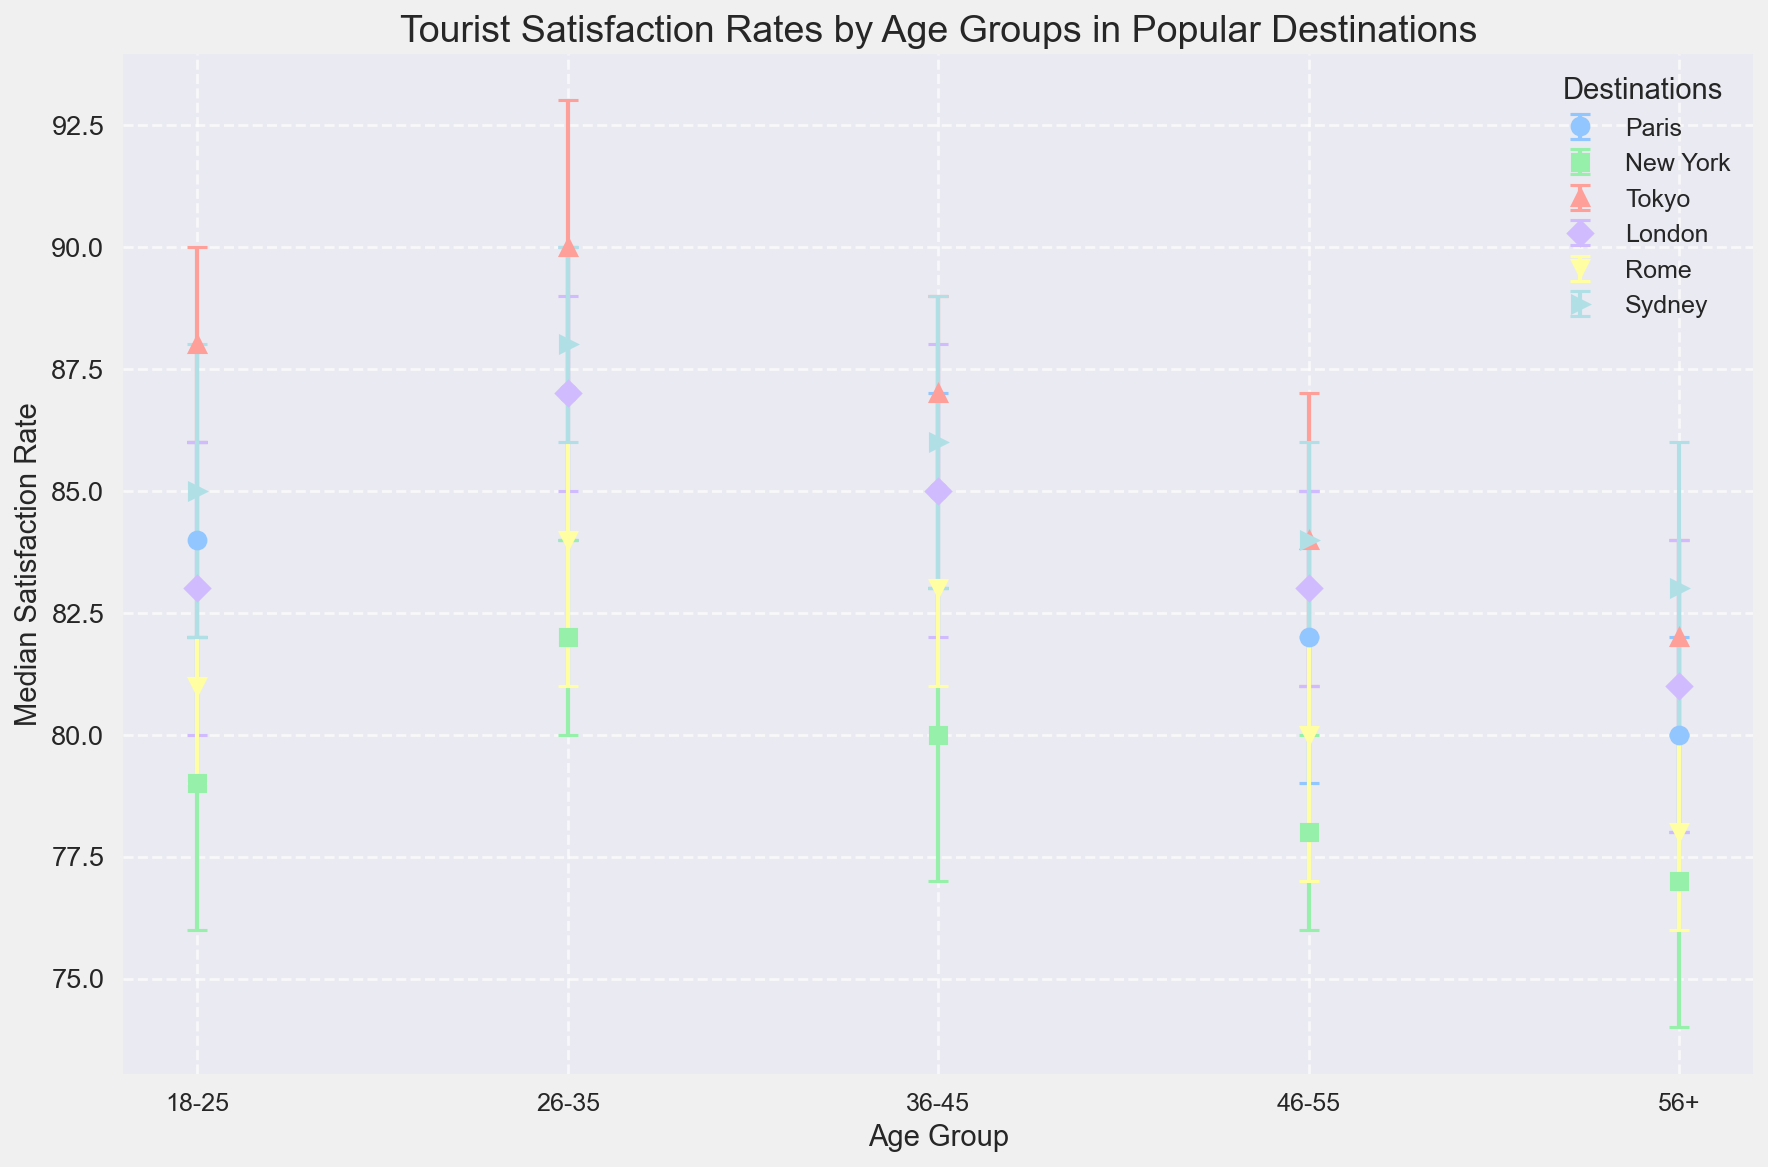Which age group has the highest tourist satisfaction rate in Tokyo? Look at the bars representing Tokyo. The 26-35 age group has the highest bar on the satisfaction rate axis.
Answer: 26-35 Which destination has the lowest median satisfaction rate for the 56+ age group? Locate the satisfaction rates for the 56+ age group across all destinations. New York shows the lowest value at 77.
Answer: New York Compare the error margins for the 18-25 age group in Paris and Sydney. Which one is higher? Look at the error bars for the 18-25 age group in both Paris and Sydney. Sydney has an error margin of 3 while Paris has an error margin of 2.
Answer: Sydney What is the difference in satisfaction rates between the 36-45 age group and 56+ age group in London? For London, the satisfaction rate for the 36-45 age group is 85, and for the 56+ age group, it's 81. The difference is 85 - 81.
Answer: 4 Which age group has the closest satisfaction rate between Paris and Rome? Compare the satisfaction rates for each age group between Paris and Rome. The 46-55 age group has similar values: Paris at 82 and Rome at 80.
Answer: 46-55 For the 26-35 age group, does Tokyo have a higher or lower satisfaction rate compared to New York? Compare the satisfaction rates for the 26-35 age group between Tokyo (90) and New York (82). Tokyo's rate is higher.
Answer: Higher If we average the satisfaction rates for the 46-55 age group across all destinations, what would it be? Sum the satisfaction rates for the 46-55 age group across all destinations: (Paris 82, New York 78, Tokyo 84, London 83, Rome 80, Sydney 84). Average = (82 + 78 + 84 + 83 + 80 + 84) / 6.
Answer: 81.83 Looking at the visual lengths of the satisfaction rates, does London have higher satisfaction for 36-45 or 26-35 age group? Observe the bar lengths for the 36-45 and 26-35 age groups in London. The 26-35 age group has a higher bar (87) than the 36-45 age group (85).
Answer: 26-35 Which age group in New York shows the highest variability in satisfaction (largest error margin)? Look at the error bars for each age group in New York. The 18-25 age group has the largest error margin of 3.
Answer: 18-25 